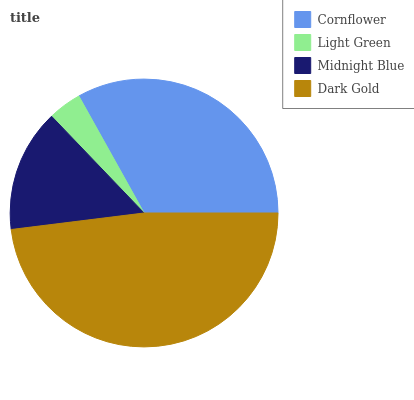Is Light Green the minimum?
Answer yes or no. Yes. Is Dark Gold the maximum?
Answer yes or no. Yes. Is Midnight Blue the minimum?
Answer yes or no. No. Is Midnight Blue the maximum?
Answer yes or no. No. Is Midnight Blue greater than Light Green?
Answer yes or no. Yes. Is Light Green less than Midnight Blue?
Answer yes or no. Yes. Is Light Green greater than Midnight Blue?
Answer yes or no. No. Is Midnight Blue less than Light Green?
Answer yes or no. No. Is Cornflower the high median?
Answer yes or no. Yes. Is Midnight Blue the low median?
Answer yes or no. Yes. Is Dark Gold the high median?
Answer yes or no. No. Is Dark Gold the low median?
Answer yes or no. No. 